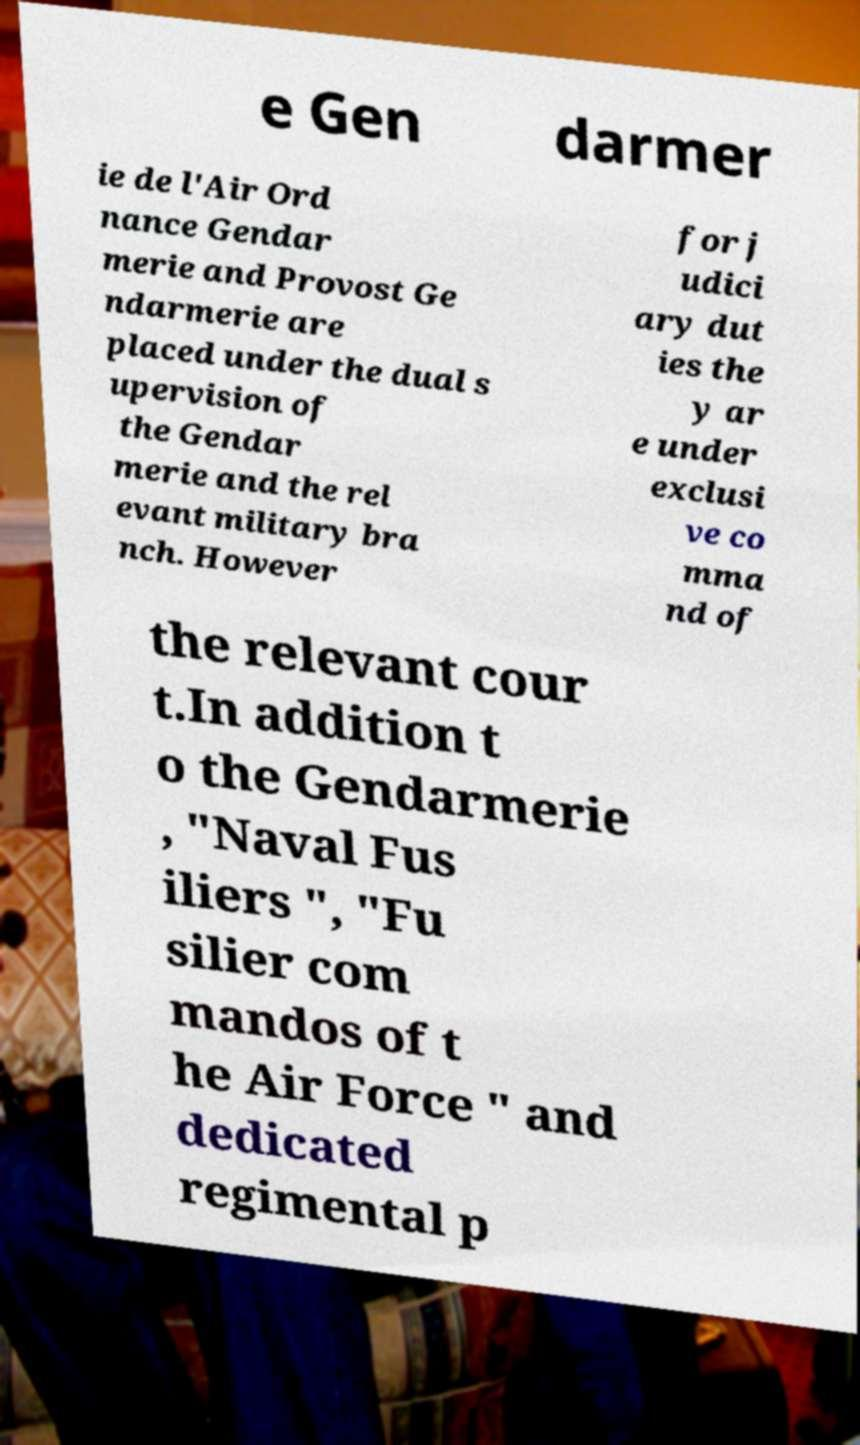Please identify and transcribe the text found in this image. e Gen darmer ie de l'Air Ord nance Gendar merie and Provost Ge ndarmerie are placed under the dual s upervision of the Gendar merie and the rel evant military bra nch. However for j udici ary dut ies the y ar e under exclusi ve co mma nd of the relevant cour t.In addition t o the Gendarmerie , "Naval Fus iliers ", "Fu silier com mandos of t he Air Force " and dedicated regimental p 